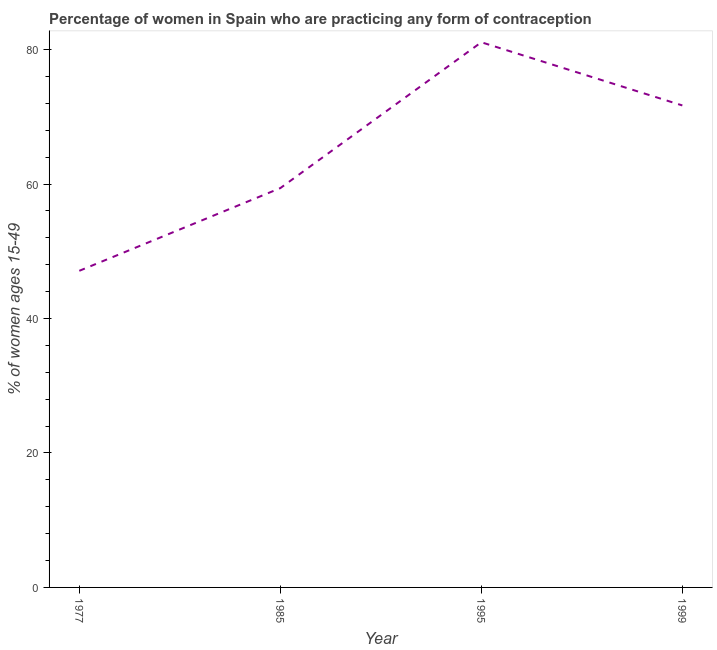What is the contraceptive prevalence in 1995?
Give a very brief answer. 81.1. Across all years, what is the maximum contraceptive prevalence?
Offer a terse response. 81.1. Across all years, what is the minimum contraceptive prevalence?
Ensure brevity in your answer.  47.1. In which year was the contraceptive prevalence minimum?
Ensure brevity in your answer.  1977. What is the sum of the contraceptive prevalence?
Offer a very short reply. 259.3. What is the difference between the contraceptive prevalence in 1995 and 1999?
Make the answer very short. 9.4. What is the average contraceptive prevalence per year?
Make the answer very short. 64.83. What is the median contraceptive prevalence?
Your answer should be compact. 65.55. In how many years, is the contraceptive prevalence greater than 12 %?
Provide a succinct answer. 4. Do a majority of the years between 1977 and 1985 (inclusive) have contraceptive prevalence greater than 36 %?
Keep it short and to the point. Yes. What is the ratio of the contraceptive prevalence in 1977 to that in 1995?
Your answer should be compact. 0.58. What is the difference between the highest and the second highest contraceptive prevalence?
Keep it short and to the point. 9.4. Is the sum of the contraceptive prevalence in 1995 and 1999 greater than the maximum contraceptive prevalence across all years?
Your answer should be compact. Yes. What is the difference between the highest and the lowest contraceptive prevalence?
Offer a terse response. 34. In how many years, is the contraceptive prevalence greater than the average contraceptive prevalence taken over all years?
Offer a terse response. 2. Does the contraceptive prevalence monotonically increase over the years?
Ensure brevity in your answer.  No. How many lines are there?
Provide a short and direct response. 1. What is the difference between two consecutive major ticks on the Y-axis?
Provide a short and direct response. 20. Are the values on the major ticks of Y-axis written in scientific E-notation?
Give a very brief answer. No. Does the graph contain grids?
Your answer should be very brief. No. What is the title of the graph?
Make the answer very short. Percentage of women in Spain who are practicing any form of contraception. What is the label or title of the X-axis?
Provide a succinct answer. Year. What is the label or title of the Y-axis?
Give a very brief answer. % of women ages 15-49. What is the % of women ages 15-49 of 1977?
Keep it short and to the point. 47.1. What is the % of women ages 15-49 in 1985?
Your answer should be very brief. 59.4. What is the % of women ages 15-49 in 1995?
Offer a very short reply. 81.1. What is the % of women ages 15-49 of 1999?
Your response must be concise. 71.7. What is the difference between the % of women ages 15-49 in 1977 and 1985?
Keep it short and to the point. -12.3. What is the difference between the % of women ages 15-49 in 1977 and 1995?
Provide a short and direct response. -34. What is the difference between the % of women ages 15-49 in 1977 and 1999?
Your response must be concise. -24.6. What is the difference between the % of women ages 15-49 in 1985 and 1995?
Your answer should be compact. -21.7. What is the ratio of the % of women ages 15-49 in 1977 to that in 1985?
Your answer should be compact. 0.79. What is the ratio of the % of women ages 15-49 in 1977 to that in 1995?
Your answer should be very brief. 0.58. What is the ratio of the % of women ages 15-49 in 1977 to that in 1999?
Your answer should be very brief. 0.66. What is the ratio of the % of women ages 15-49 in 1985 to that in 1995?
Offer a terse response. 0.73. What is the ratio of the % of women ages 15-49 in 1985 to that in 1999?
Offer a terse response. 0.83. What is the ratio of the % of women ages 15-49 in 1995 to that in 1999?
Offer a terse response. 1.13. 